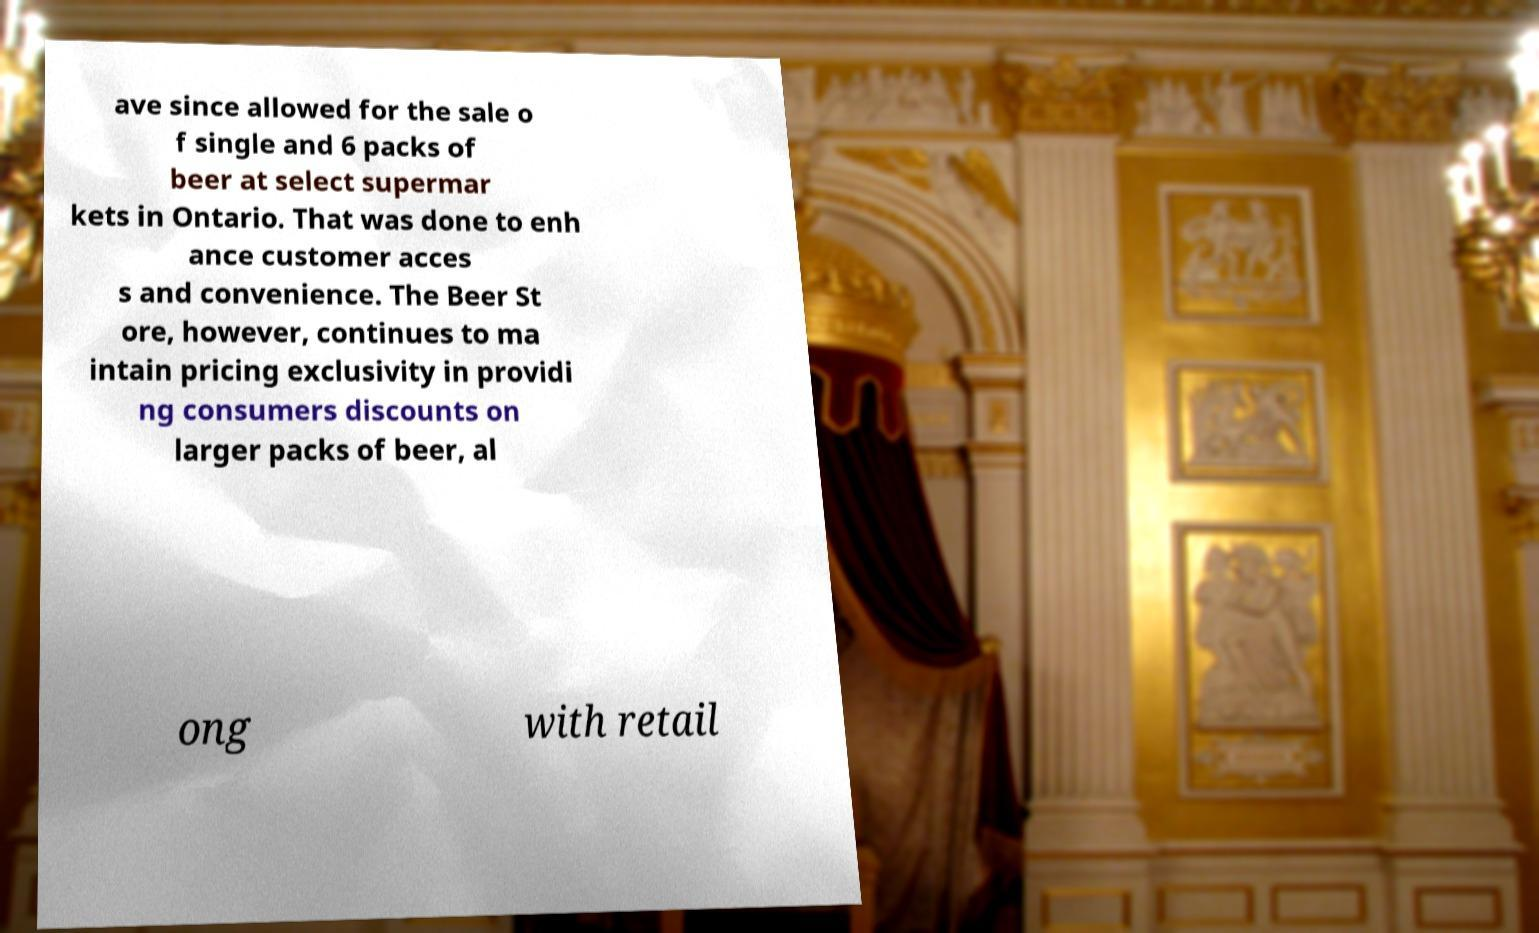Could you extract and type out the text from this image? ave since allowed for the sale o f single and 6 packs of beer at select supermar kets in Ontario. That was done to enh ance customer acces s and convenience. The Beer St ore, however, continues to ma intain pricing exclusivity in providi ng consumers discounts on larger packs of beer, al ong with retail 